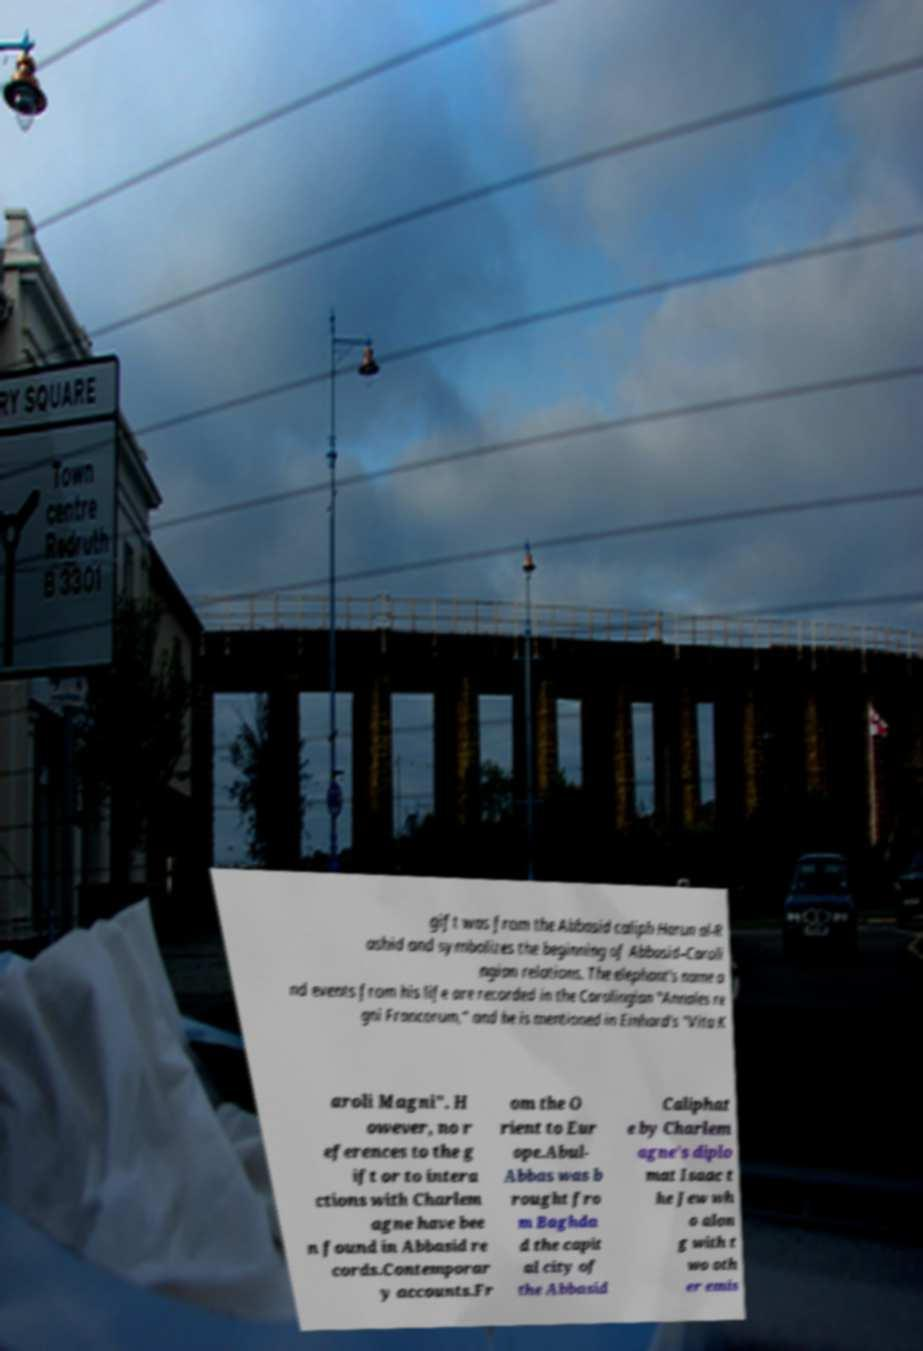What messages or text are displayed in this image? I need them in a readable, typed format. gift was from the Abbasid caliph Harun al-R ashid and symbolizes the beginning of Abbasid–Caroli ngian relations. The elephant's name a nd events from his life are recorded in the Carolingian "Annales re gni Francorum," and he is mentioned in Einhard's "Vita K aroli Magni". H owever, no r eferences to the g ift or to intera ctions with Charlem agne have bee n found in Abbasid re cords.Contemporar y accounts.Fr om the O rient to Eur ope.Abul- Abbas was b rought fro m Baghda d the capit al city of the Abbasid Caliphat e by Charlem agne's diplo mat Isaac t he Jew wh o alon g with t wo oth er emis 